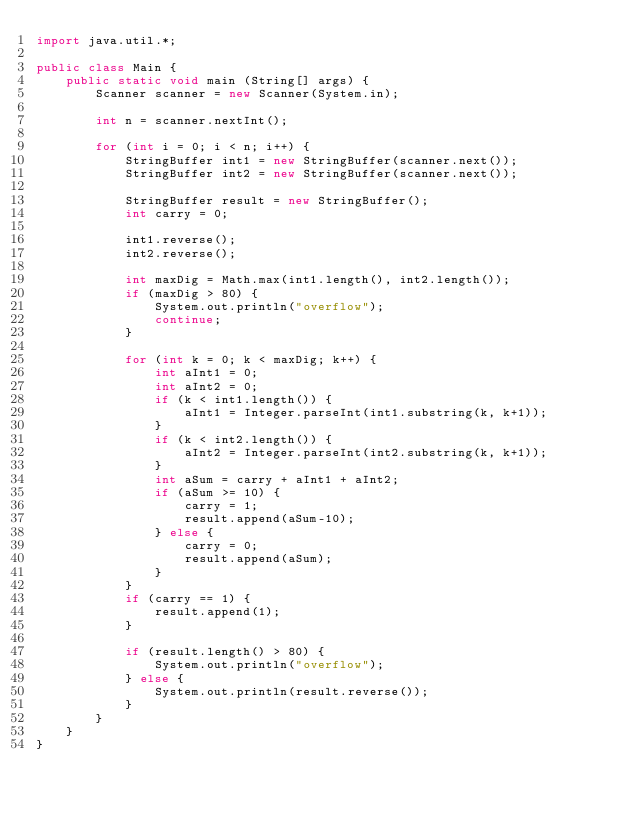<code> <loc_0><loc_0><loc_500><loc_500><_Java_>import java.util.*;

public class Main {
    public static void main (String[] args) {
        Scanner scanner = new Scanner(System.in);
        
        int n = scanner.nextInt();
        
        for (int i = 0; i < n; i++) {
            StringBuffer int1 = new StringBuffer(scanner.next());
            StringBuffer int2 = new StringBuffer(scanner.next());

            StringBuffer result = new StringBuffer();
            int carry = 0;

            int1.reverse();
            int2.reverse();

            int maxDig = Math.max(int1.length(), int2.length());
            if (maxDig > 80) {
                System.out.println("overflow");
                continue;
            }

            for (int k = 0; k < maxDig; k++) {
                int aInt1 = 0;
                int aInt2 = 0;
                if (k < int1.length()) {
                    aInt1 = Integer.parseInt(int1.substring(k, k+1));
                }
                if (k < int2.length()) {
                    aInt2 = Integer.parseInt(int2.substring(k, k+1));
                }
                int aSum = carry + aInt1 + aInt2;
                if (aSum >= 10) {
                    carry = 1;
                    result.append(aSum-10);
                } else {
                    carry = 0;
                    result.append(aSum);
                }
            }
            if (carry == 1) {
                result.append(1);
            }
            
            if (result.length() > 80) {
                System.out.println("overflow");
            } else {
                System.out.println(result.reverse());
            }
        }
    }
}</code> 